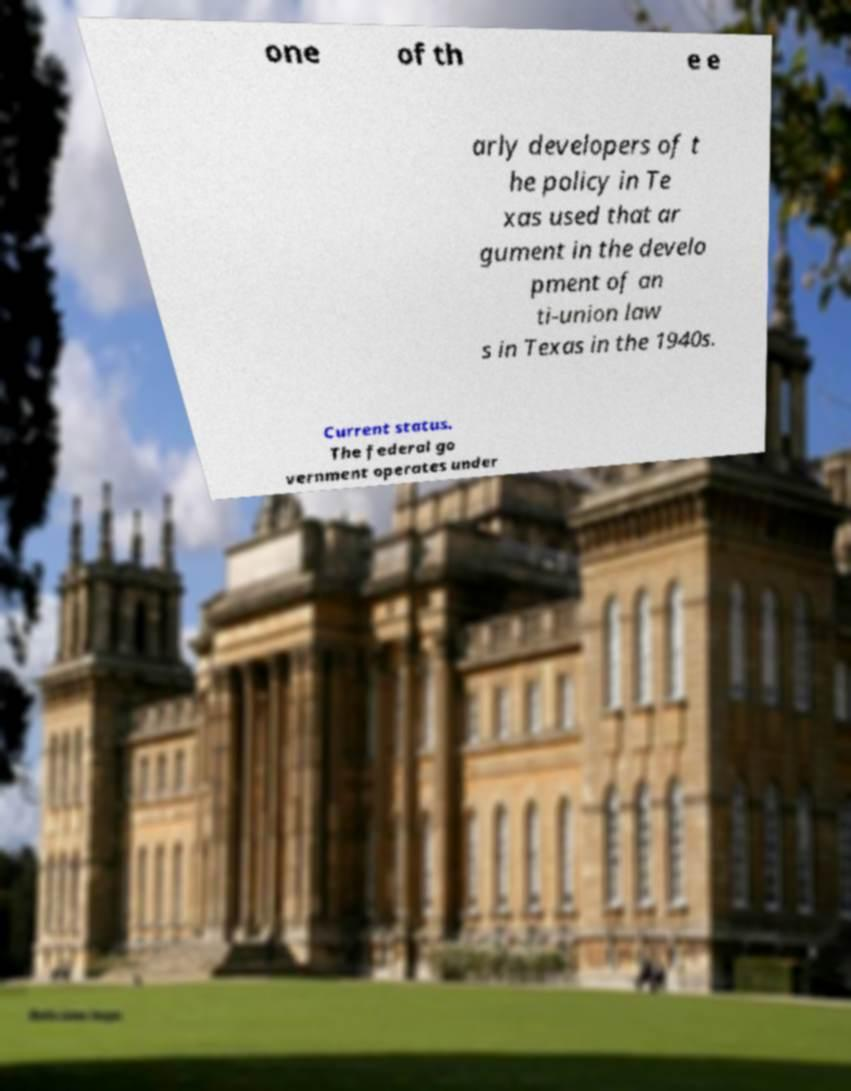Please read and relay the text visible in this image. What does it say? one of th e e arly developers of t he policy in Te xas used that ar gument in the develo pment of an ti-union law s in Texas in the 1940s. Current status. The federal go vernment operates under 